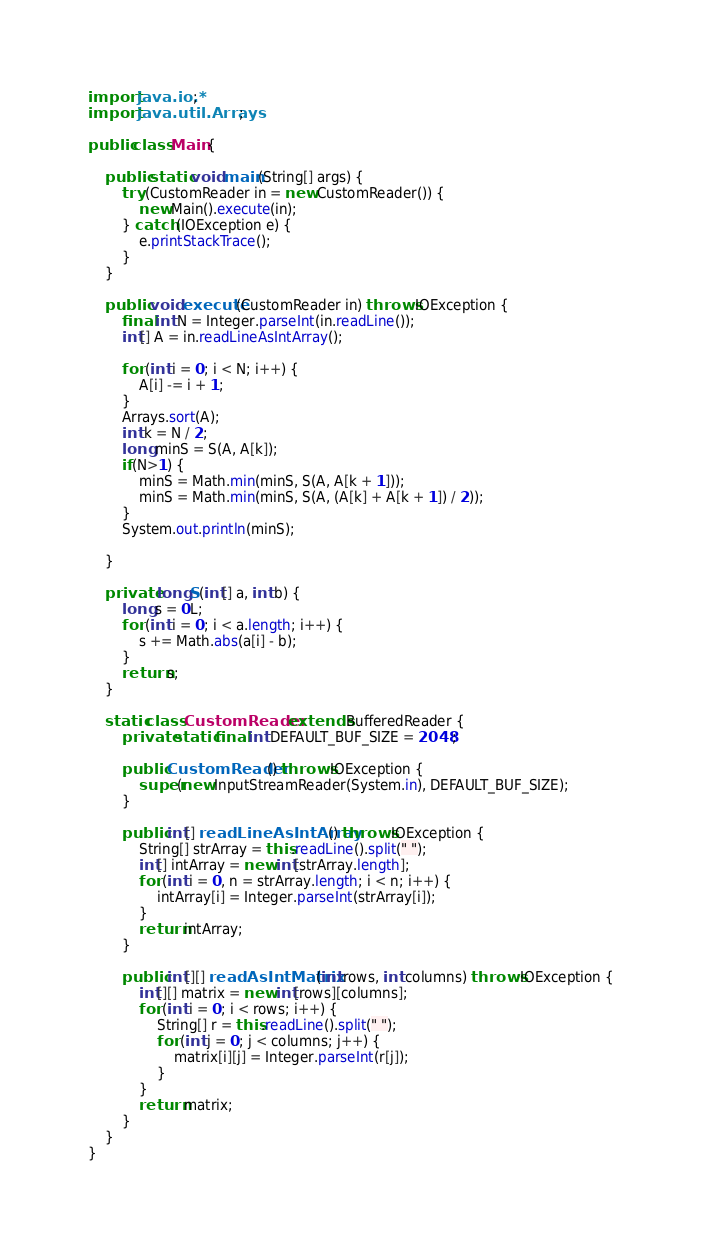<code> <loc_0><loc_0><loc_500><loc_500><_Java_>import java.io.*;
import java.util.Arrays;

public class Main {

    public static void main(String[] args) {
        try (CustomReader in = new CustomReader()) {
            new Main().execute(in);
        } catch (IOException e) {
            e.printStackTrace();
        }
    }

    public void execute(CustomReader in) throws IOException {
        final int N = Integer.parseInt(in.readLine());
        int[] A = in.readLineAsIntArray();

        for (int i = 0; i < N; i++) {
            A[i] -= i + 1;
        }
        Arrays.sort(A);
        int k = N / 2;
        long minS = S(A, A[k]);
        if(N>1) {
            minS = Math.min(minS, S(A, A[k + 1]));
            minS = Math.min(minS, S(A, (A[k] + A[k + 1]) / 2));
        }
        System.out.println(minS);

    }

    private long S(int[] a, int b) {
        long s = 0L;
        for (int i = 0; i < a.length; i++) {
            s += Math.abs(a[i] - b);
        }
        return s;
    }

    static class CustomReader extends BufferedReader {
        private static final int DEFAULT_BUF_SIZE = 2048;

        public CustomReader() throws IOException {
            super(new InputStreamReader(System.in), DEFAULT_BUF_SIZE);
        }

        public int[] readLineAsIntArray() throws IOException {
            String[] strArray = this.readLine().split(" ");
            int[] intArray = new int[strArray.length];
            for (int i = 0, n = strArray.length; i < n; i++) {
                intArray[i] = Integer.parseInt(strArray[i]);
            }
            return intArray;
        }

        public int[][] readAsIntMatrix(int rows, int columns) throws IOException {
            int[][] matrix = new int[rows][columns];
            for (int i = 0; i < rows; i++) {
                String[] r = this.readLine().split(" ");
                for (int j = 0; j < columns; j++) {
                    matrix[i][j] = Integer.parseInt(r[j]);
                }
            }
            return matrix;
        }
    }
}</code> 